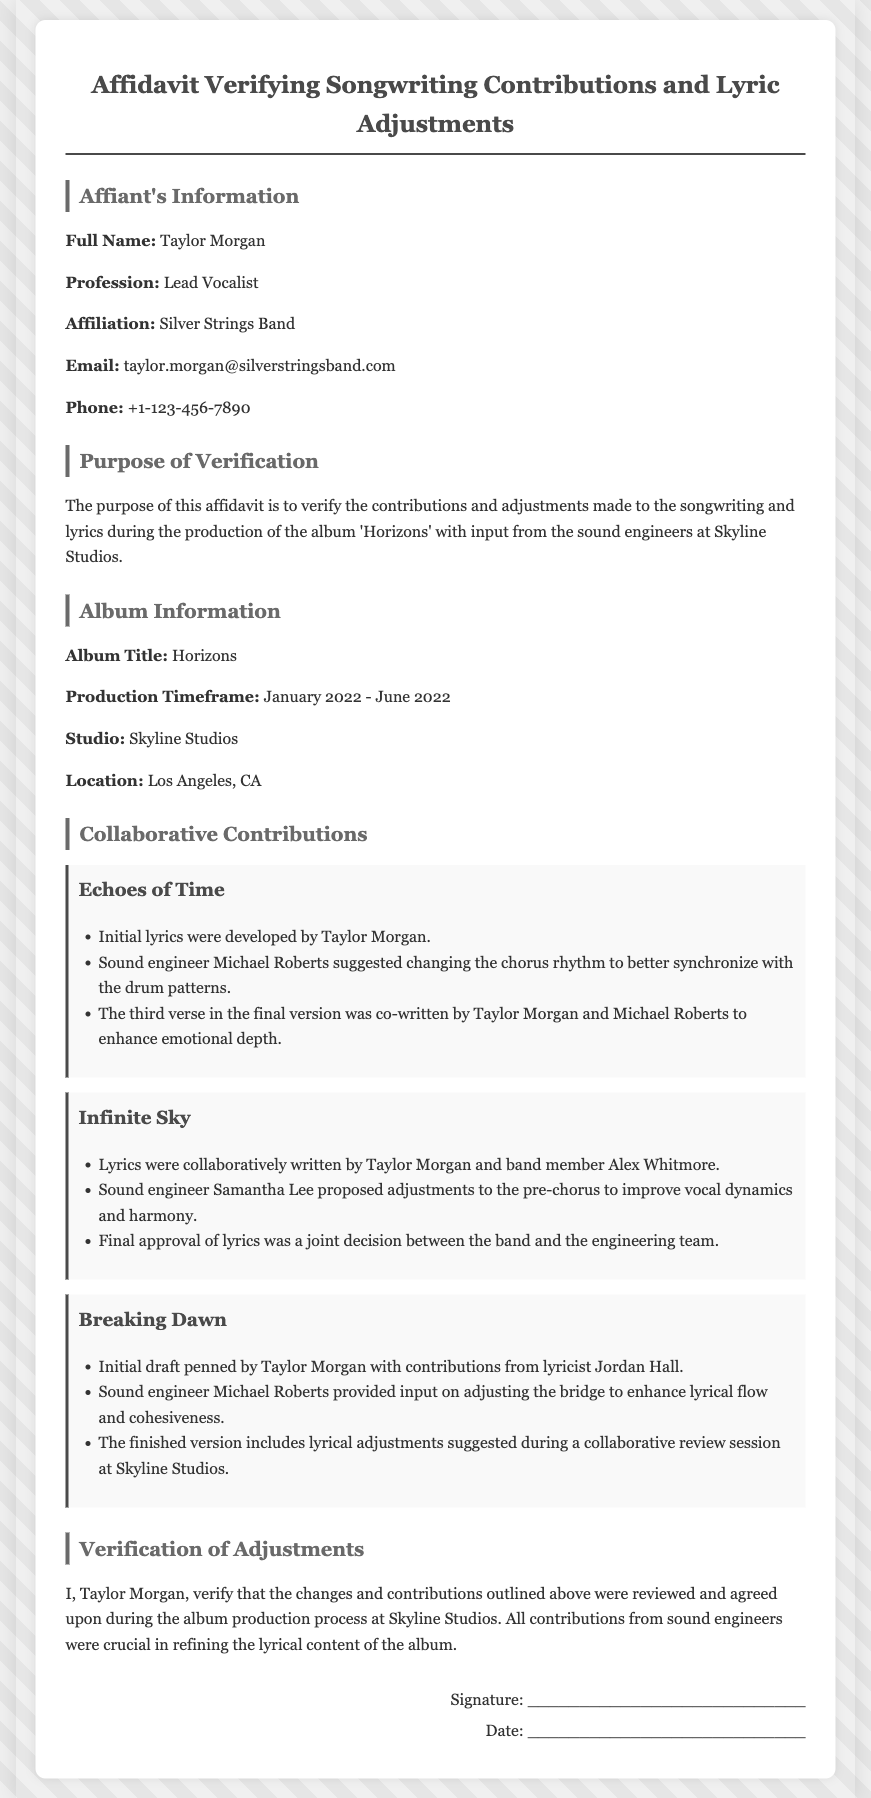What is the full name of the affiant? The affiant's full name is listed in the Affiant's Information section.
Answer: Taylor Morgan What is the profession of the affiant? The profession is mentioned right after the full name in the document.
Answer: Lead Vocalist What is the title of the album? The album title is specified in the Album Information section.
Answer: Horizons Who suggested changes to the chorus rhythm in "Echoes of Time"? This information is found in the Collaborative Contributions section for that song.
Answer: Michael Roberts During what timeframe was the album produced? The production timeframe is detailed in the Album Information section.
Answer: January 2022 - June 2022 What was the studio's location? The location of Skyline Studios is mentioned in the Album Information section.
Answer: Los Angeles, CA How was the final approval of lyrics for "Infinite Sky" decided? This is addressed in the Collaborative Contributions section under that song.
Answer: Joint decision What role did the sound engineers play in the affidavit? The role is described in the Verification of Adjustments section of the affidavit.
Answer: Crucial in refining Who co-wrote the third verse of "Echoes of Time"? This information is outlined in the Collaborative Contributions section for that song.
Answer: Taylor Morgan and Michael Roberts What statement verifies the contributions? The verification statement is found in the Verification of Adjustments section of the document.
Answer: I, Taylor Morgan, verify.. 